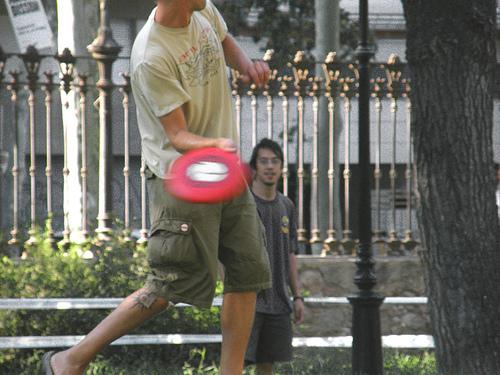What is the man in the foreground doing?
Give a very brief answer. Throwing frisbee. What color are the second mans shorts?
Give a very brief answer. Black. Are they in a park?
Concise answer only. Yes. 